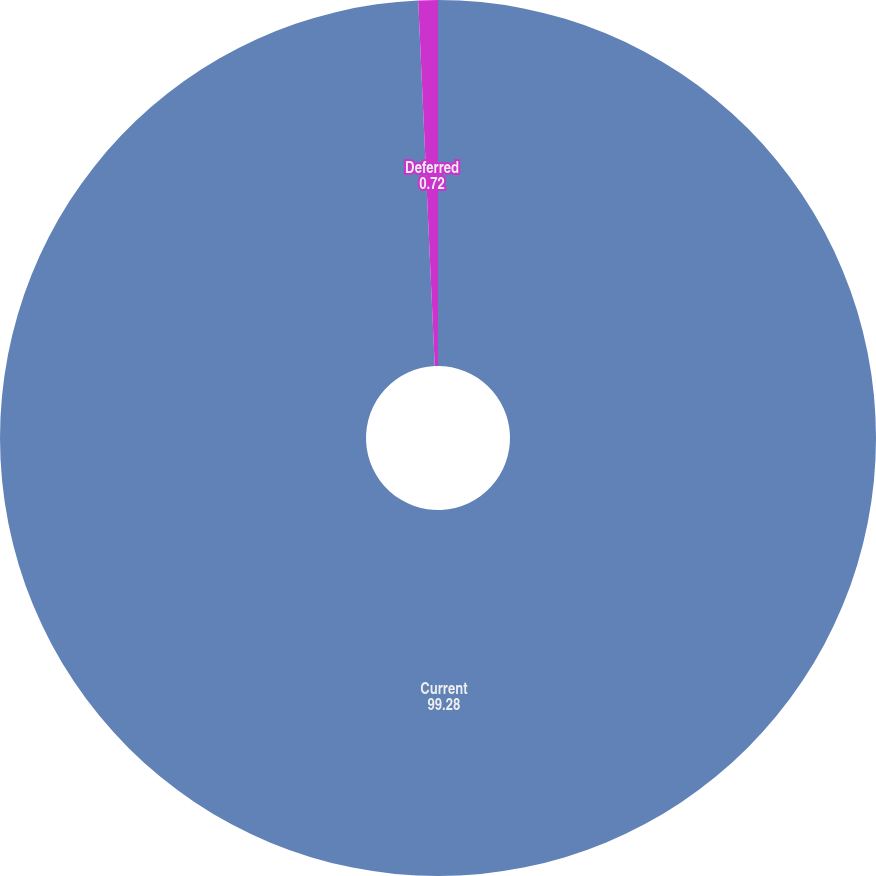Convert chart to OTSL. <chart><loc_0><loc_0><loc_500><loc_500><pie_chart><fcel>Current<fcel>Deferred<nl><fcel>99.28%<fcel>0.72%<nl></chart> 